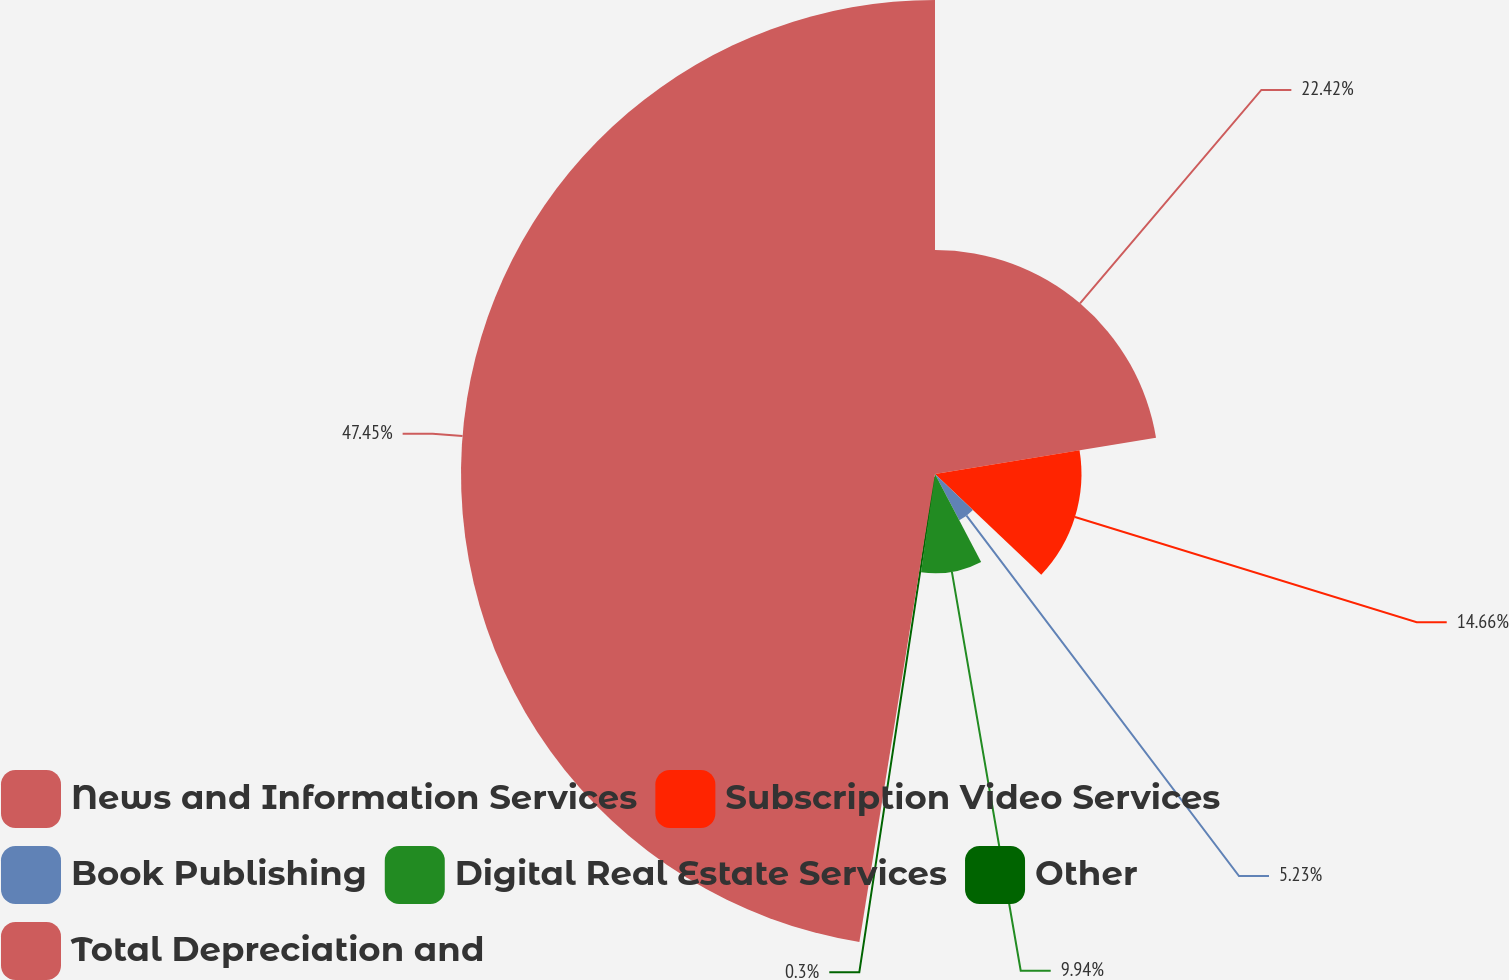Convert chart. <chart><loc_0><loc_0><loc_500><loc_500><pie_chart><fcel>News and Information Services<fcel>Subscription Video Services<fcel>Book Publishing<fcel>Digital Real Estate Services<fcel>Other<fcel>Total Depreciation and<nl><fcel>22.42%<fcel>14.66%<fcel>5.23%<fcel>9.94%<fcel>0.3%<fcel>47.45%<nl></chart> 